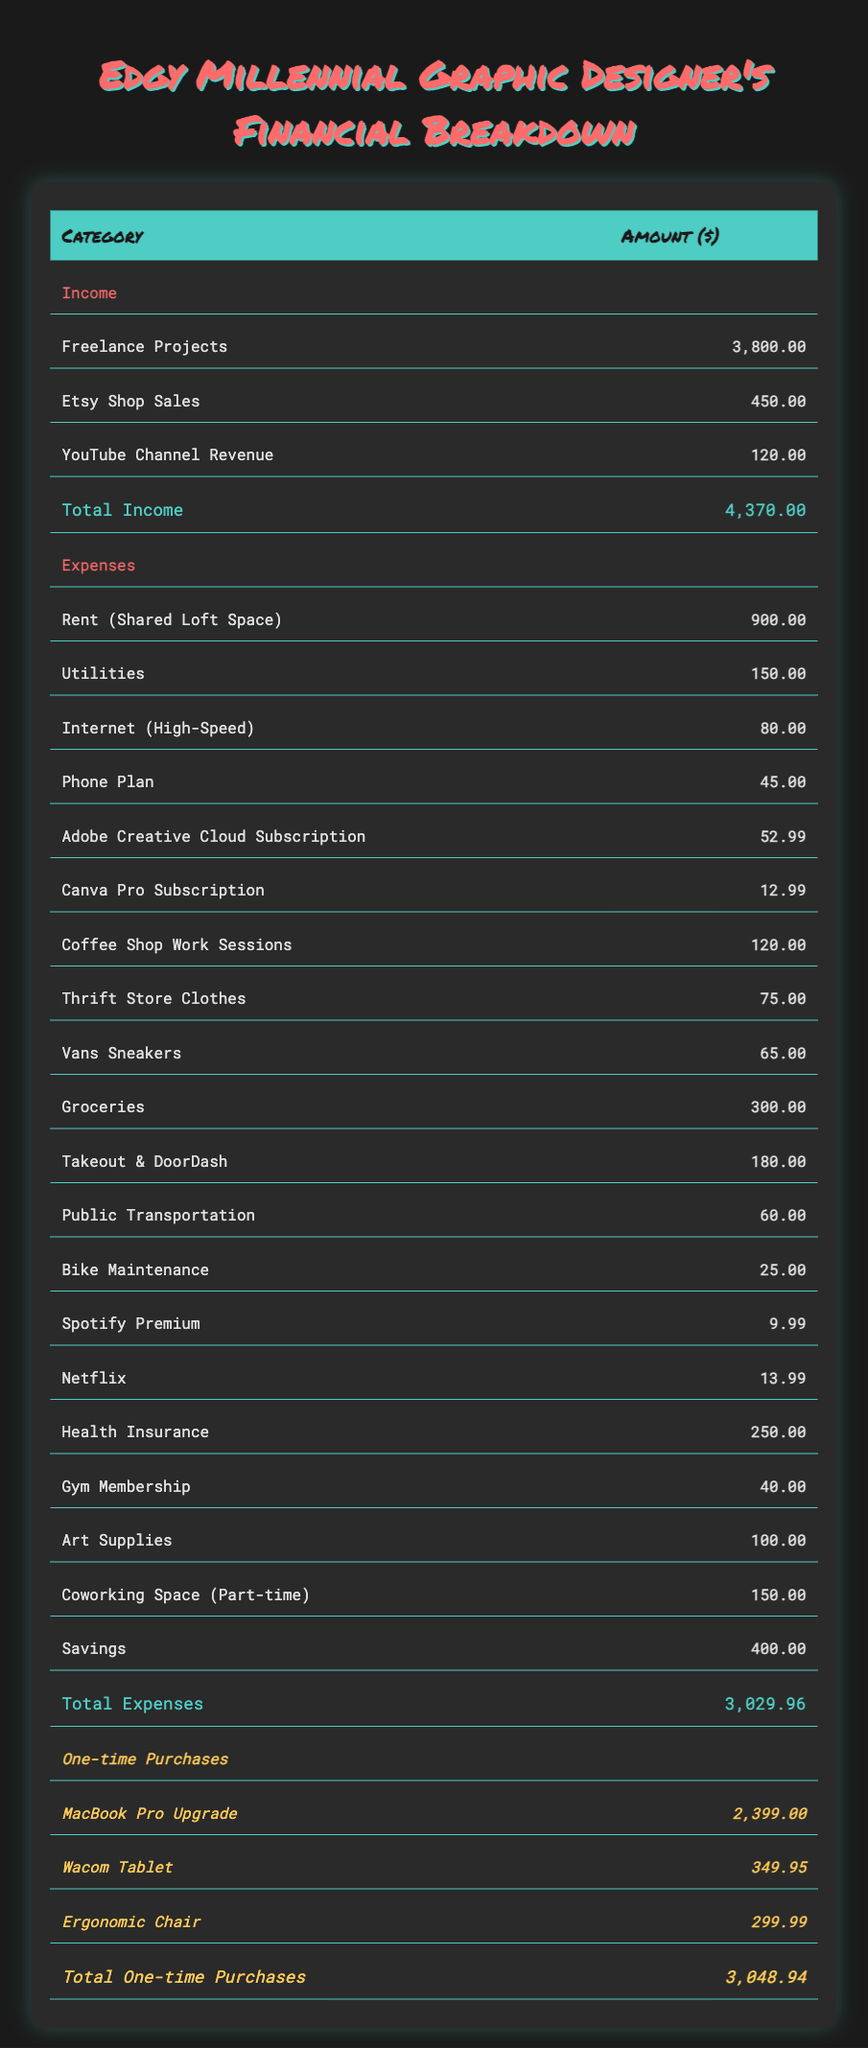What's the total income for the month? The total income is the sum of all income sources: Freelance Projects ($3800) + Etsy Shop Sales ($450) + YouTube Channel Revenue ($120). Adding these together gives $3800 + $450 + $120 = $4370.
Answer: 4370 What are the total monthly expenses? To find the total monthly expenses, sum all the expense categories: Rent ($900) + Utilities ($150) + Internet ($80) + Phone Plan ($45) + Adobe Subscription ($52.99) + Canva Subscription ($12.99) + Coffee Shop Sessions ($120) + Thrift Store Clothes ($75) + Vans Sneakers ($65) + Groceries ($300) + Takeout ($180) + Public Transport ($60) + Bike Maintenance ($25) + Spotify ($9.99) + Netflix ($13.99) + Health Insurance ($250) + Gym Membership ($40) + Art Supplies ($100) + Coworking Space ($150) + Savings ($400). Adding these gives $3029.96.
Answer: 3029.96 Did the designer spend more on one-time purchases than monthly expenses? To answer this, compare total one-time purchases ($3048.94) with total monthly expenses ($3029.96). Since $3048.94 > $3029.96, the answer is yes.
Answer: Yes What was the average monthly expense for subscriptions (Adobe Creative Cloud and Canva Pro)? Find the total of the subscription costs: Adobe ($52.99) + Canva ($12.99) = $65.98. There are 2 subscription items, so the average is 65.98 / 2 = 32.99.
Answer: 32.99 Which category has the highest cost, and what is the amount? By scanning the expense categories, Rent ($900) has the highest cost compared to all other line items listed.
Answer: Rent (Shared Loft Space), 900 How much did the designer spend on health-related expenses (Health Insurance and Gym Membership)? Calculate the total health-related expenses: Health Insurance ($250) + Gym Membership ($40) = $290.
Answer: 290 If the designer wanted to reduce their coffee shop expenses by half, how much would they save? Coffee shop work sessions cost $120. Reducing this by half would save $120 / 2 = $60.
Answer: 60 What is the total amount spent on both thrift store clothes and Vans sneakers? Add the expenses for Thrift Store Clothes ($75) and Vans Sneakers ($65): $75 + $65 = $140.
Answer: 140 What percentage of the total income does the designer save each month? First, calculate savings which is $400. Then, use the formula (savings / total income) * 100, giving (400 / 4370) * 100 = approximately 9.15%.
Answer: 9.15% 